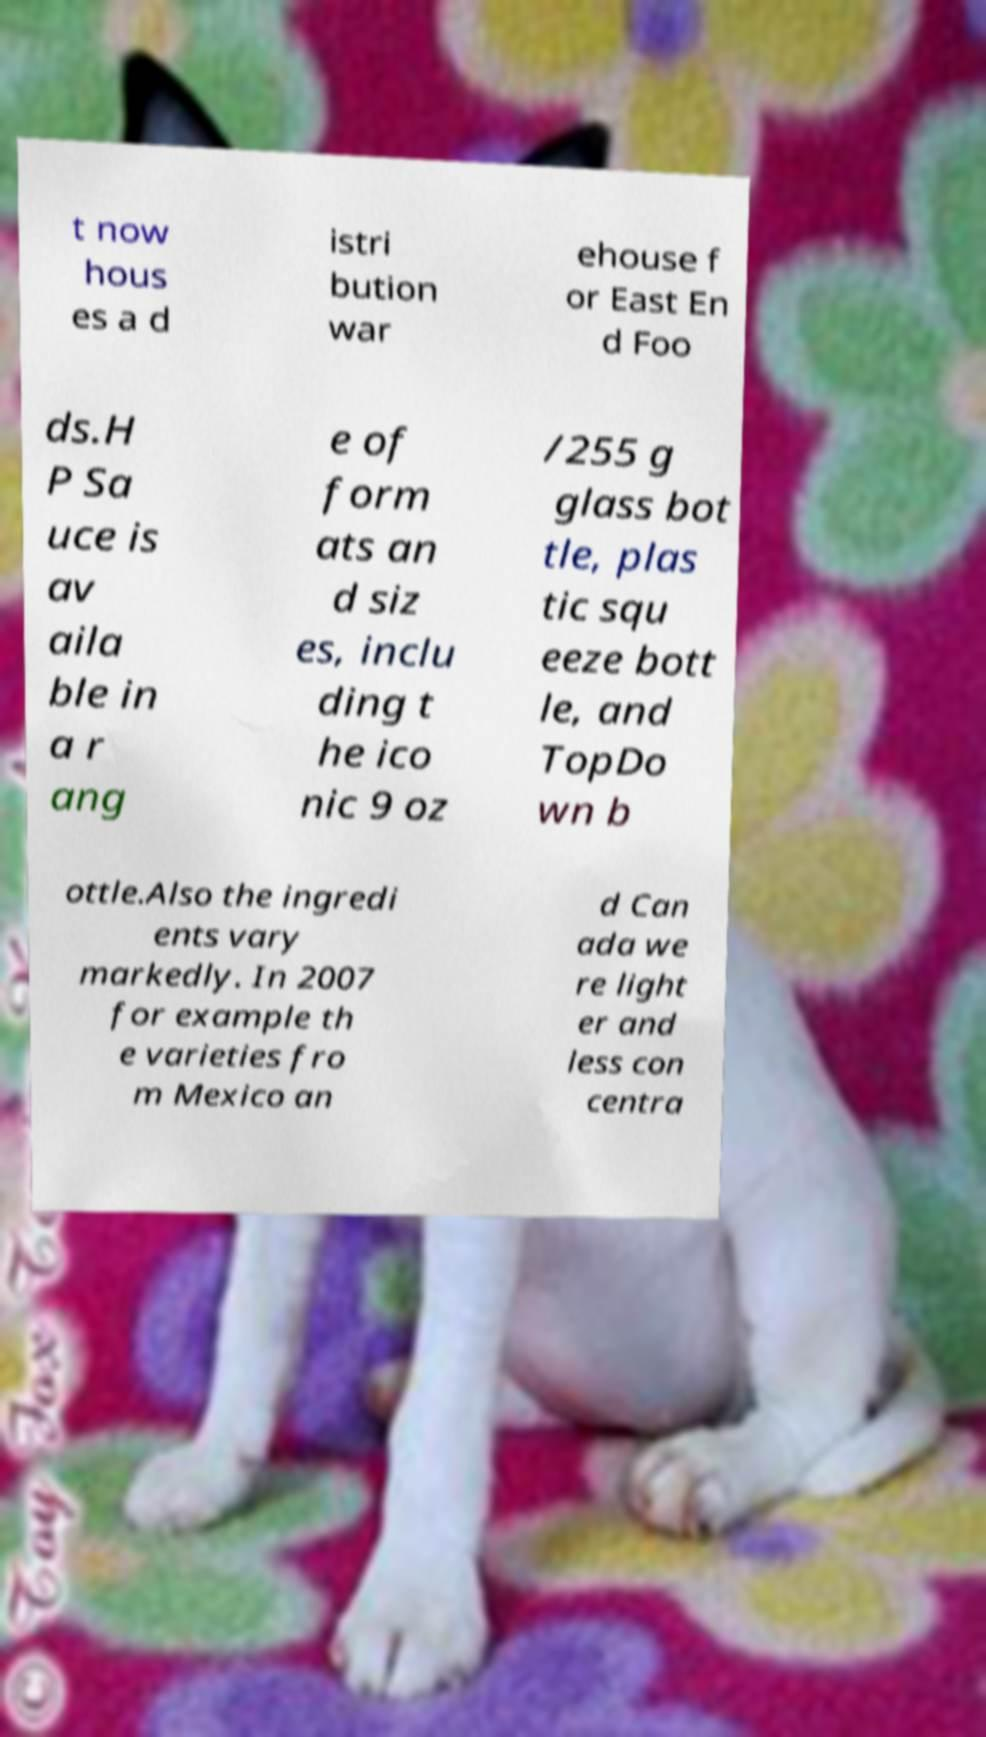Could you assist in decoding the text presented in this image and type it out clearly? t now hous es a d istri bution war ehouse f or East En d Foo ds.H P Sa uce is av aila ble in a r ang e of form ats an d siz es, inclu ding t he ico nic 9 oz /255 g glass bot tle, plas tic squ eeze bott le, and TopDo wn b ottle.Also the ingredi ents vary markedly. In 2007 for example th e varieties fro m Mexico an d Can ada we re light er and less con centra 